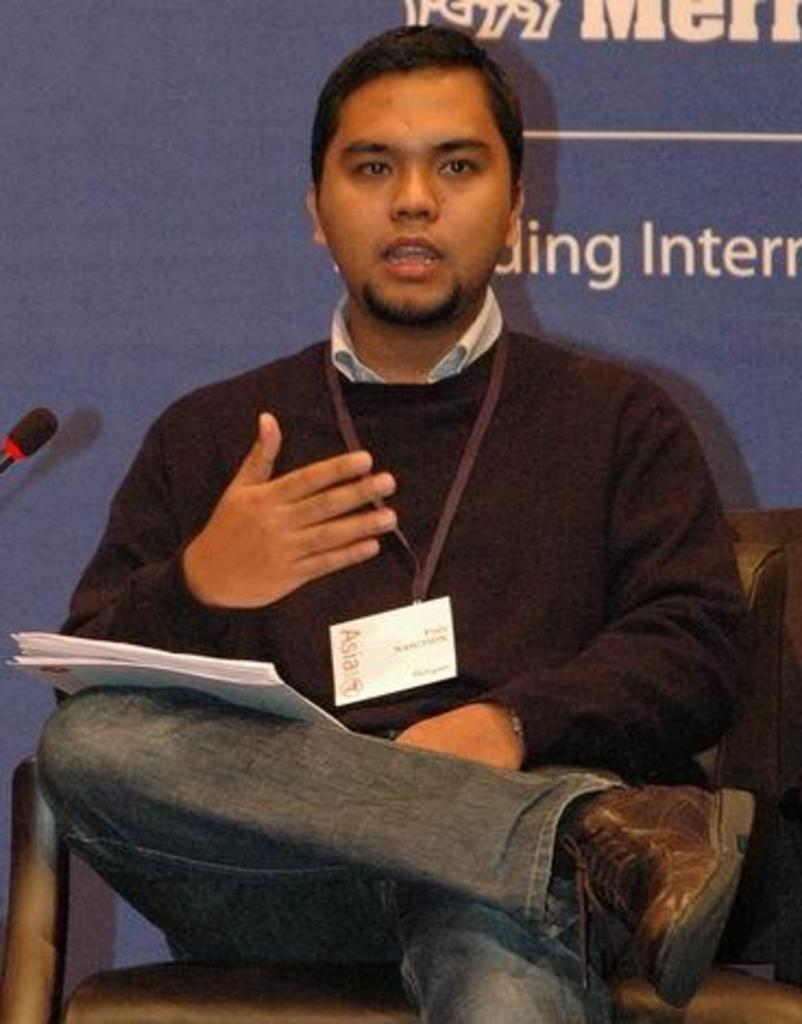What is the man in the image doing? The man is sitting on a chair in the image. What is on the man's leg? The man has papers on his leg. What can be seen in the background of the image? There is a hoarding and a microphone in the background of the image. Can you see any operations happening in the image? There is no operation taking place in the image. Are there any rats visible in the image? There are no rats present in the image. 